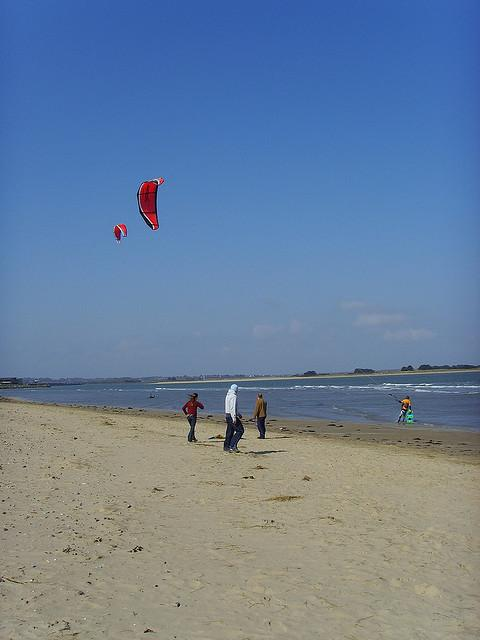What touches the feet of the people holding the airborn sails? Please explain your reasoning. water. The water will eventually come in to get their feet wet. 